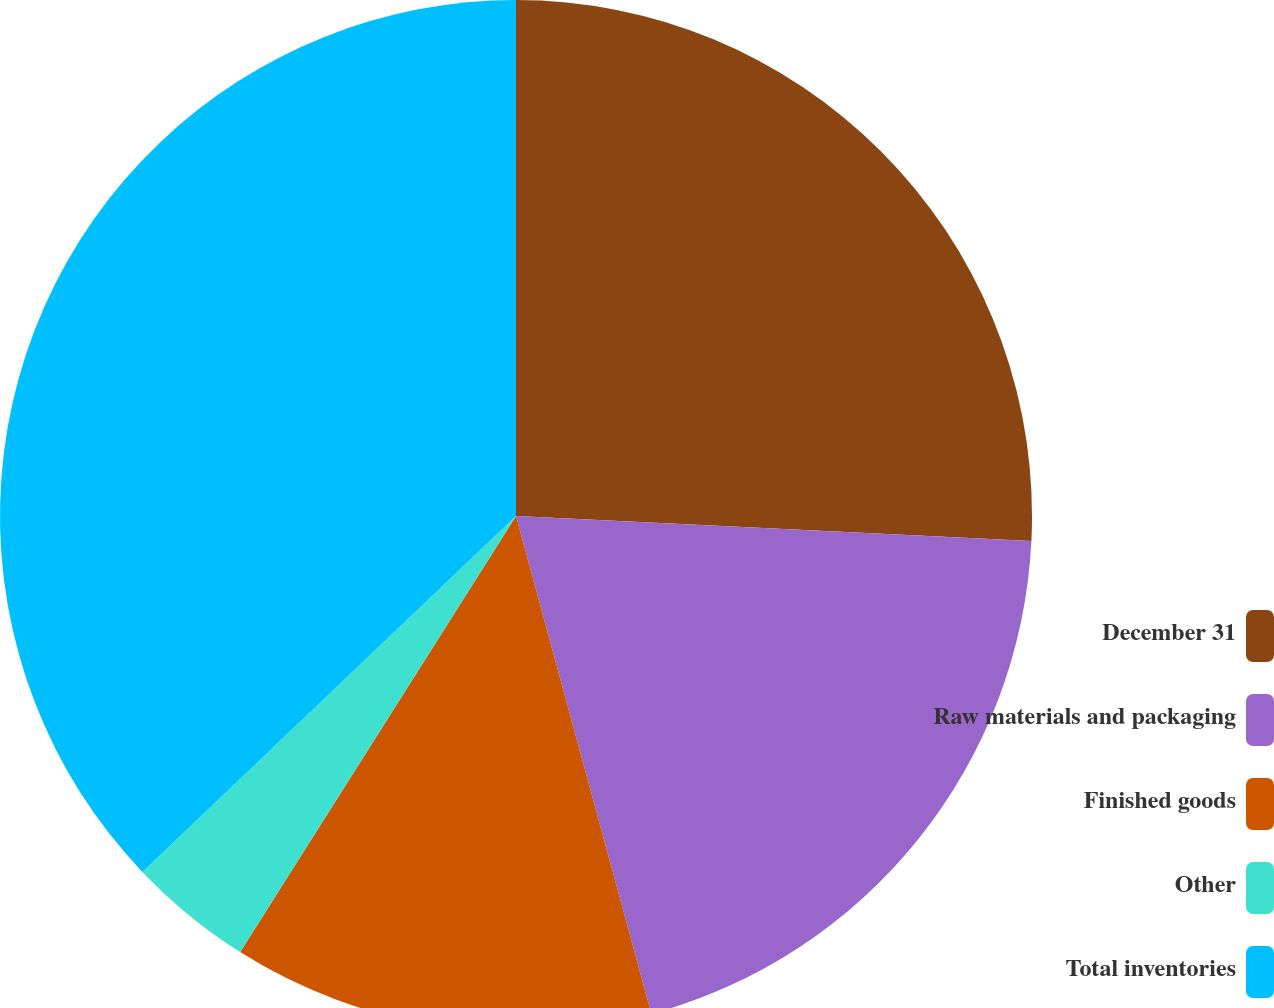Convert chart. <chart><loc_0><loc_0><loc_500><loc_500><pie_chart><fcel>December 31<fcel>Raw materials and packaging<fcel>Finished goods<fcel>Other<fcel>Total inventories<nl><fcel>25.77%<fcel>20.0%<fcel>13.2%<fcel>3.91%<fcel>37.11%<nl></chart> 